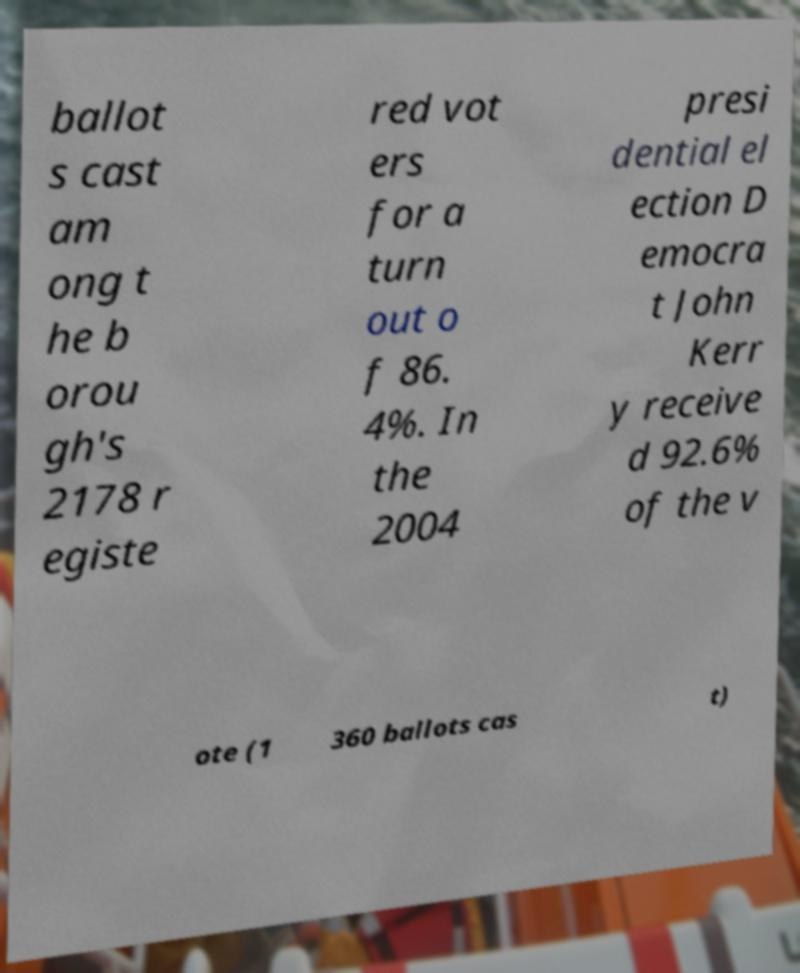Could you assist in decoding the text presented in this image and type it out clearly? ballot s cast am ong t he b orou gh's 2178 r egiste red vot ers for a turn out o f 86. 4%. In the 2004 presi dential el ection D emocra t John Kerr y receive d 92.6% of the v ote (1 360 ballots cas t) 